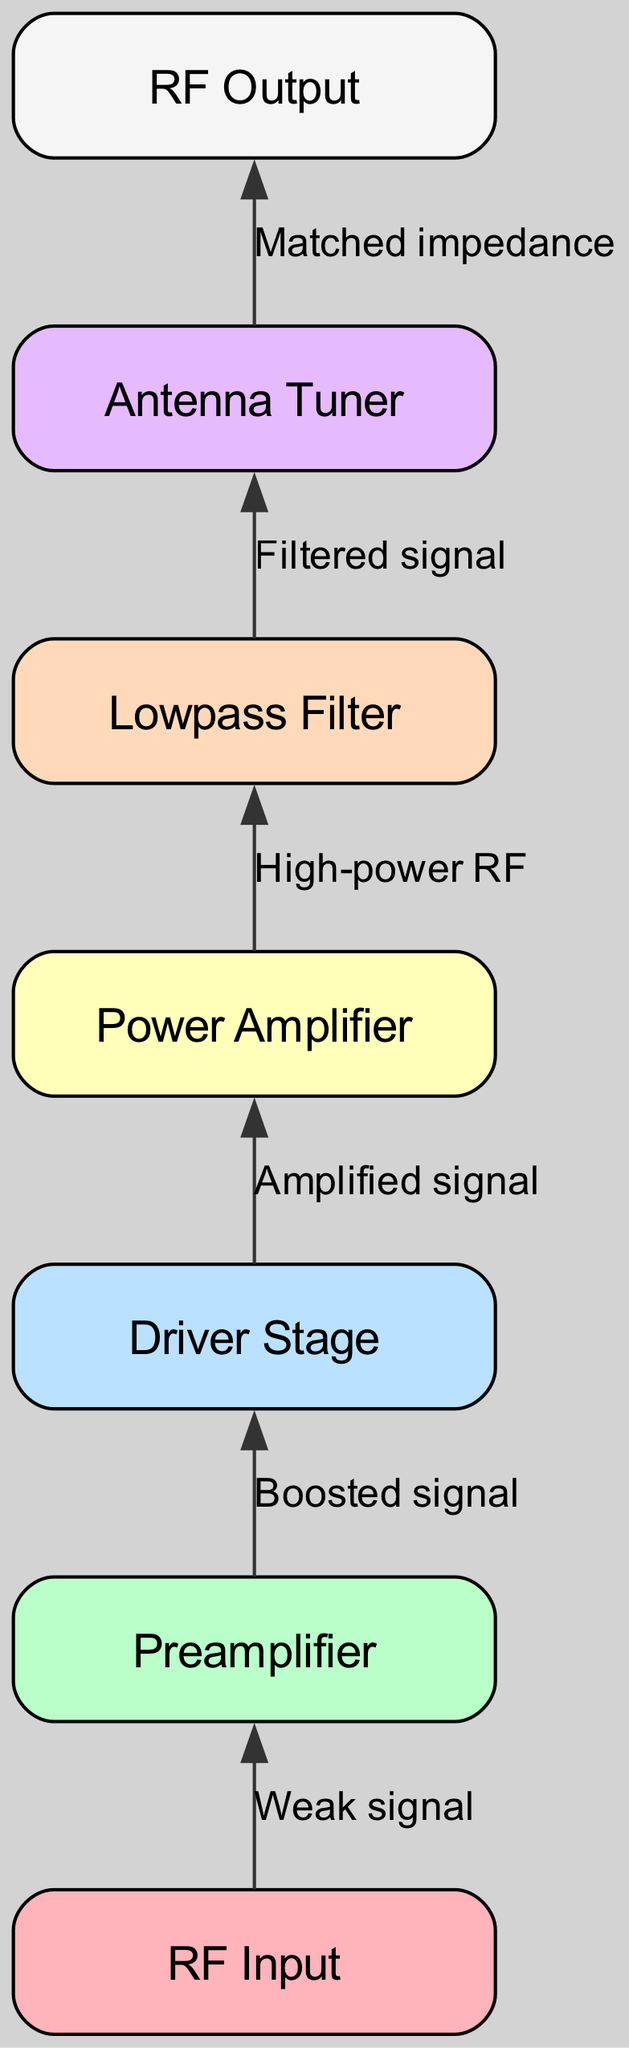What is the first component in the flow chart? The first component in the flow chart is labeled as “RF Input.” It is the starting point of the signal flow in the amplifier setup.
Answer: RF Input How many components are in the diagram? The diagram has a total of seven components, which are connected sequentially to represent the flow of signals.
Answer: 7 What connects to the Preamplifier? The Preamplifier receives input from the RF Input, which transmits a weak signal to it. This connection is essential for boosting the signal.
Answer: RF Input What is the output of the Power Amplifier? The output of the Power Amplifier is described as “High-power RF,” indicating that it produces a signal with increased power suitable for radio transmission.
Answer: High-power RF What is the function of the Lowpass Filter? The Lowpass Filter serves to provide a “Filtered signal,” which is crucial to eliminate unwanted frequencies and harmonics from the amplified RF signal before it reaches the antenna tuner.
Answer: Filtered signal Which component ensures impedance matching? The component that ensures impedance matching is the Antenna Tuner. This device is essential for optimizing the radio frequency signal for transmission by matching the output impedance to that of the antenna system.
Answer: Antenna Tuner In which order do the signals flow from the RF Input to the RF Output? The order of the signal flow is RF Input -> Preamplifier -> Driver Stage -> Power Amplifier -> Lowpass Filter -> Antenna Tuner -> RF Output. This sequential flow illustrates how the signal is amplified and filtered before transmission.
Answer: RF Input -> Preamplifier -> Driver Stage -> Power Amplifier -> Lowpass Filter -> Antenna Tuner -> RF Output What type of signal does the Driver Stage receive? The Driver Stage receives a “Boosted signal” from the Preamplifier, which is already amplified from the original weak signal provided at RF Input. This boosts the signal further for the next amplification stage.
Answer: Boosted signal What comes after the Lowpass Filter in the signal flow? After the Lowpass Filter, the next component in the signal flow is the Antenna Tuner, which prepares the signal for proper transmission by matching impedance.
Answer: Antenna Tuner 